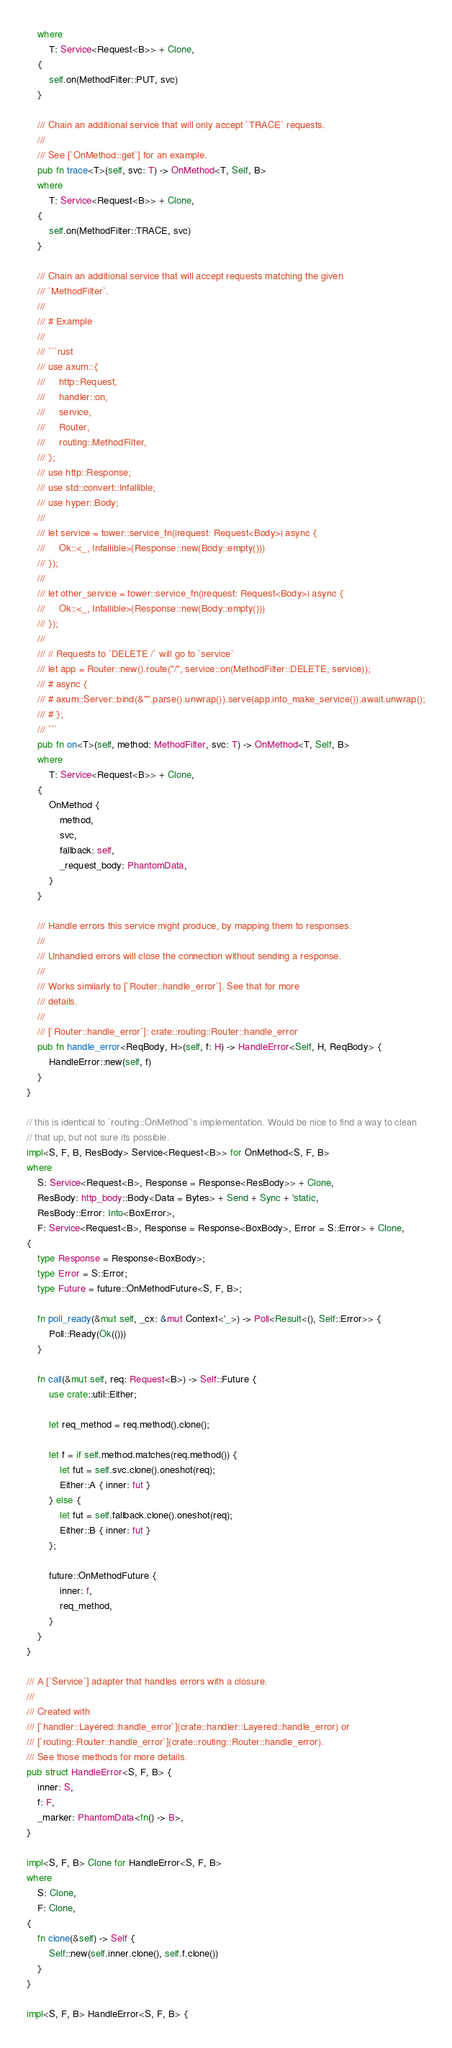<code> <loc_0><loc_0><loc_500><loc_500><_Rust_>    where
        T: Service<Request<B>> + Clone,
    {
        self.on(MethodFilter::PUT, svc)
    }

    /// Chain an additional service that will only accept `TRACE` requests.
    ///
    /// See [`OnMethod::get`] for an example.
    pub fn trace<T>(self, svc: T) -> OnMethod<T, Self, B>
    where
        T: Service<Request<B>> + Clone,
    {
        self.on(MethodFilter::TRACE, svc)
    }

    /// Chain an additional service that will accept requests matching the given
    /// `MethodFilter`.
    ///
    /// # Example
    ///
    /// ```rust
    /// use axum::{
    ///     http::Request,
    ///     handler::on,
    ///     service,
    ///     Router,
    ///     routing::MethodFilter,
    /// };
    /// use http::Response;
    /// use std::convert::Infallible;
    /// use hyper::Body;
    ///
    /// let service = tower::service_fn(|request: Request<Body>| async {
    ///     Ok::<_, Infallible>(Response::new(Body::empty()))
    /// });
    ///
    /// let other_service = tower::service_fn(|request: Request<Body>| async {
    ///     Ok::<_, Infallible>(Response::new(Body::empty()))
    /// });
    ///
    /// // Requests to `DELETE /` will go to `service`
    /// let app = Router::new().route("/", service::on(MethodFilter::DELETE, service));
    /// # async {
    /// # axum::Server::bind(&"".parse().unwrap()).serve(app.into_make_service()).await.unwrap();
    /// # };
    /// ```
    pub fn on<T>(self, method: MethodFilter, svc: T) -> OnMethod<T, Self, B>
    where
        T: Service<Request<B>> + Clone,
    {
        OnMethod {
            method,
            svc,
            fallback: self,
            _request_body: PhantomData,
        }
    }

    /// Handle errors this service might produce, by mapping them to responses.
    ///
    /// Unhandled errors will close the connection without sending a response.
    ///
    /// Works similarly to [`Router::handle_error`]. See that for more
    /// details.
    ///
    /// [`Router::handle_error`]: crate::routing::Router::handle_error
    pub fn handle_error<ReqBody, H>(self, f: H) -> HandleError<Self, H, ReqBody> {
        HandleError::new(self, f)
    }
}

// this is identical to `routing::OnMethod`'s implementation. Would be nice to find a way to clean
// that up, but not sure its possible.
impl<S, F, B, ResBody> Service<Request<B>> for OnMethod<S, F, B>
where
    S: Service<Request<B>, Response = Response<ResBody>> + Clone,
    ResBody: http_body::Body<Data = Bytes> + Send + Sync + 'static,
    ResBody::Error: Into<BoxError>,
    F: Service<Request<B>, Response = Response<BoxBody>, Error = S::Error> + Clone,
{
    type Response = Response<BoxBody>;
    type Error = S::Error;
    type Future = future::OnMethodFuture<S, F, B>;

    fn poll_ready(&mut self, _cx: &mut Context<'_>) -> Poll<Result<(), Self::Error>> {
        Poll::Ready(Ok(()))
    }

    fn call(&mut self, req: Request<B>) -> Self::Future {
        use crate::util::Either;

        let req_method = req.method().clone();

        let f = if self.method.matches(req.method()) {
            let fut = self.svc.clone().oneshot(req);
            Either::A { inner: fut }
        } else {
            let fut = self.fallback.clone().oneshot(req);
            Either::B { inner: fut }
        };

        future::OnMethodFuture {
            inner: f,
            req_method,
        }
    }
}

/// A [`Service`] adapter that handles errors with a closure.
///
/// Created with
/// [`handler::Layered::handle_error`](crate::handler::Layered::handle_error) or
/// [`routing::Router::handle_error`](crate::routing::Router::handle_error).
/// See those methods for more details.
pub struct HandleError<S, F, B> {
    inner: S,
    f: F,
    _marker: PhantomData<fn() -> B>,
}

impl<S, F, B> Clone for HandleError<S, F, B>
where
    S: Clone,
    F: Clone,
{
    fn clone(&self) -> Self {
        Self::new(self.inner.clone(), self.f.clone())
    }
}

impl<S, F, B> HandleError<S, F, B> {</code> 